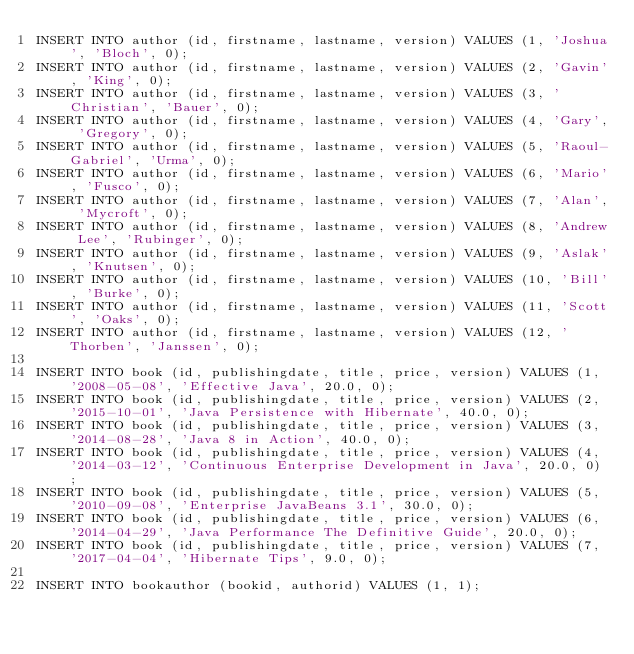<code> <loc_0><loc_0><loc_500><loc_500><_SQL_>INSERT INTO author (id, firstname, lastname, version) VALUES (1, 'Joshua', 'Bloch', 0);
INSERT INTO author (id, firstname, lastname, version) VALUES (2, 'Gavin', 'King', 0);
INSERT INTO author (id, firstname, lastname, version) VALUES (3, 'Christian', 'Bauer', 0);
INSERT INTO author (id, firstname, lastname, version) VALUES (4, 'Gary', 'Gregory', 0);
INSERT INTO author (id, firstname, lastname, version) VALUES (5, 'Raoul-Gabriel', 'Urma', 0);
INSERT INTO author (id, firstname, lastname, version) VALUES (6, 'Mario', 'Fusco', 0);
INSERT INTO author (id, firstname, lastname, version) VALUES (7, 'Alan', 'Mycroft', 0);
INSERT INTO author (id, firstname, lastname, version) VALUES (8, 'Andrew Lee', 'Rubinger', 0);
INSERT INTO author (id, firstname, lastname, version) VALUES (9, 'Aslak', 'Knutsen', 0);
INSERT INTO author (id, firstname, lastname, version) VALUES (10, 'Bill', 'Burke', 0);
INSERT INTO author (id, firstname, lastname, version) VALUES (11, 'Scott', 'Oaks', 0);
INSERT INTO author (id, firstname, lastname, version) VALUES (12, 'Thorben', 'Janssen', 0);

INSERT INTO book (id, publishingdate, title, price, version) VALUES (1, '2008-05-08', 'Effective Java', 20.0, 0);
INSERT INTO book (id, publishingdate, title, price, version) VALUES (2, '2015-10-01', 'Java Persistence with Hibernate', 40.0, 0);
INSERT INTO book (id, publishingdate, title, price, version) VALUES (3, '2014-08-28', 'Java 8 in Action', 40.0, 0);
INSERT INTO book (id, publishingdate, title, price, version) VALUES (4, '2014-03-12', 'Continuous Enterprise Development in Java', 20.0, 0);
INSERT INTO book (id, publishingdate, title, price, version) VALUES (5, '2010-09-08', 'Enterprise JavaBeans 3.1', 30.0, 0);
INSERT INTO book (id, publishingdate, title, price, version) VALUES (6, '2014-04-29', 'Java Performance The Definitive Guide', 20.0, 0);
INSERT INTO book (id, publishingdate, title, price, version) VALUES (7, '2017-04-04', 'Hibernate Tips', 9.0, 0);

INSERT INTO bookauthor (bookid, authorid) VALUES (1, 1);</code> 